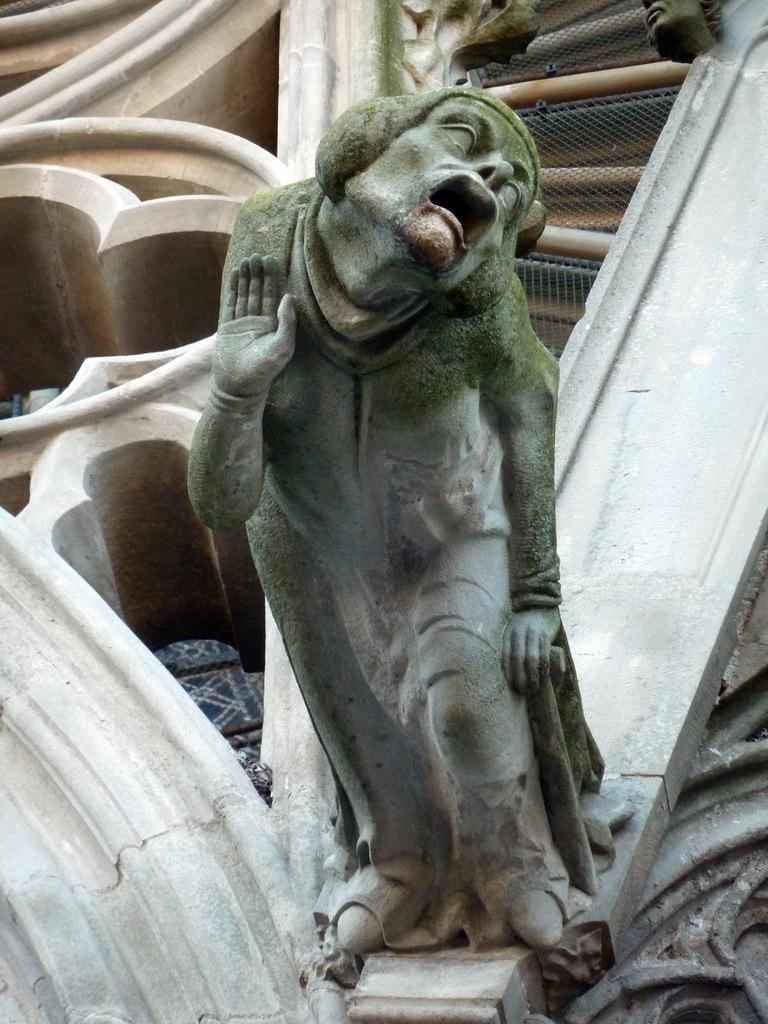How would you summarize this image in a sentence or two? In this picture is a statue. At the back there is a wall and there are sculptures on the wall and there is a fence. 